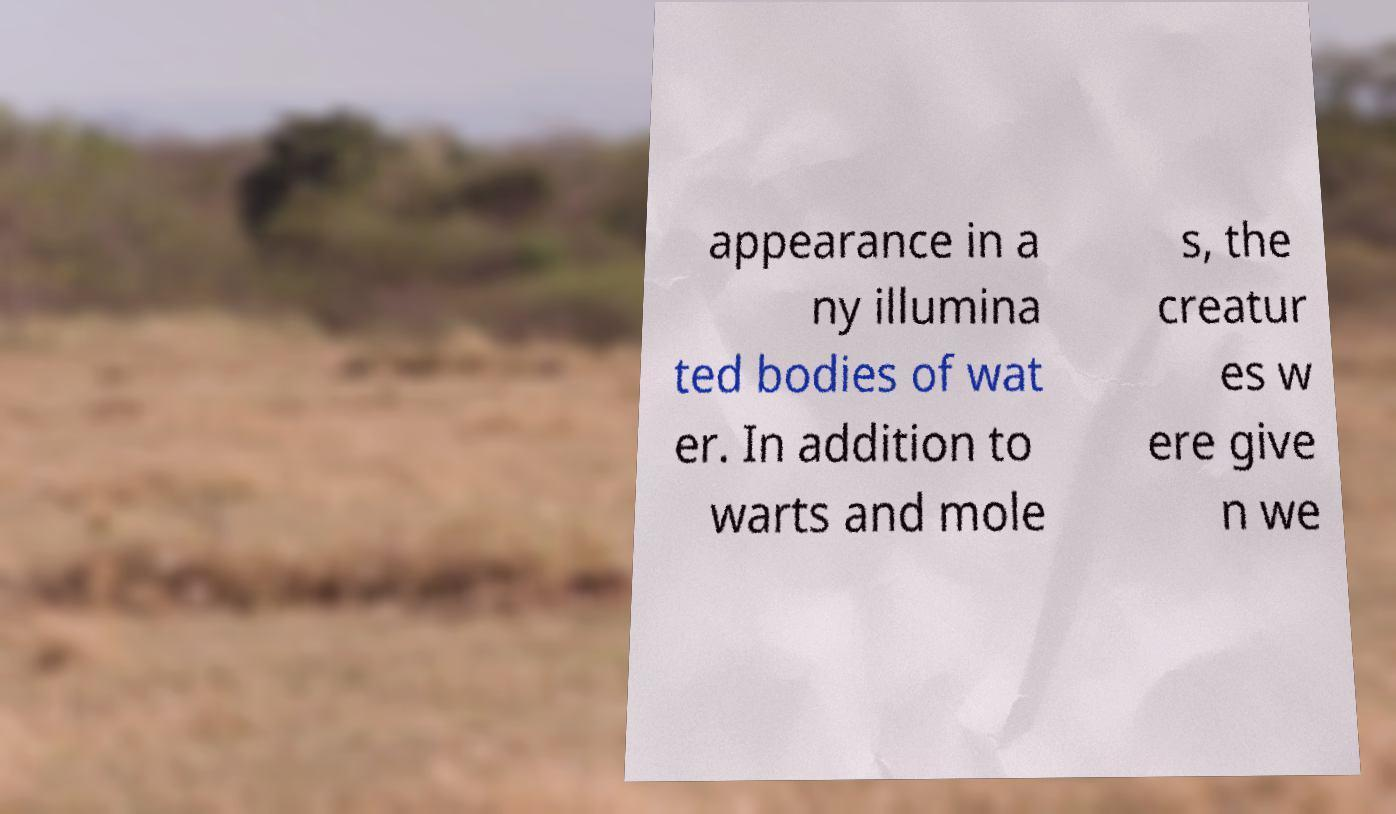Please identify and transcribe the text found in this image. appearance in a ny illumina ted bodies of wat er. In addition to warts and mole s, the creatur es w ere give n we 